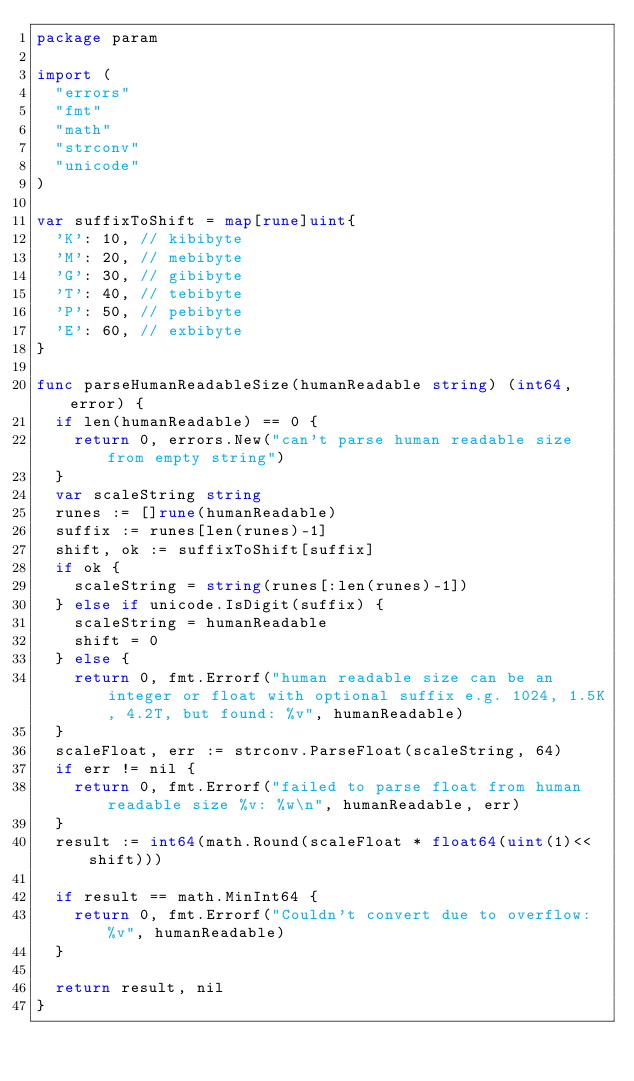<code> <loc_0><loc_0><loc_500><loc_500><_Go_>package param

import (
	"errors"
	"fmt"
	"math"
	"strconv"
	"unicode"
)

var suffixToShift = map[rune]uint{
	'K': 10, // kibibyte
	'M': 20, // mebibyte
	'G': 30, // gibibyte
	'T': 40, // tebibyte
	'P': 50, // pebibyte
	'E': 60, // exbibyte
}

func parseHumanReadableSize(humanReadable string) (int64, error) {
	if len(humanReadable) == 0 {
		return 0, errors.New("can't parse human readable size from empty string")
	}
	var scaleString string
	runes := []rune(humanReadable)
	suffix := runes[len(runes)-1]
	shift, ok := suffixToShift[suffix]
	if ok {
		scaleString = string(runes[:len(runes)-1])
	} else if unicode.IsDigit(suffix) {
		scaleString = humanReadable
		shift = 0
	} else {
		return 0, fmt.Errorf("human readable size can be an integer or float with optional suffix e.g. 1024, 1.5K, 4.2T, but found: %v", humanReadable)
	}
	scaleFloat, err := strconv.ParseFloat(scaleString, 64)
	if err != nil {
		return 0, fmt.Errorf("failed to parse float from human readable size %v: %w\n", humanReadable, err)
	}
	result := int64(math.Round(scaleFloat * float64(uint(1)<<shift)))

	if result == math.MinInt64 {
		return 0, fmt.Errorf("Couldn't convert due to overflow: %v", humanReadable)
	}

	return result, nil
}
</code> 